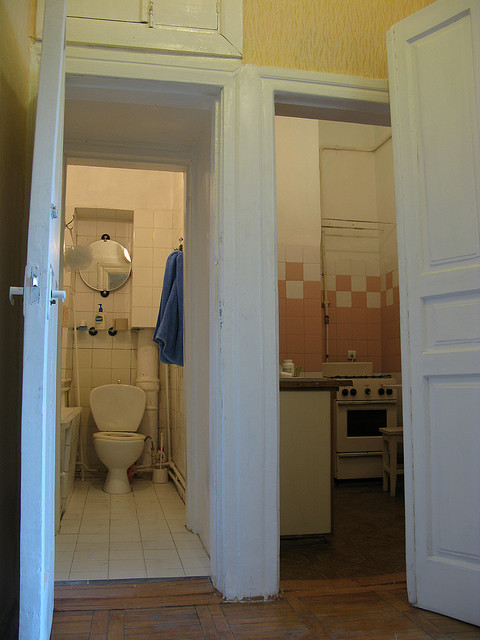<image>What type of wood is on the floor? I am not sure what type of wood is on the floor. It can be oak, hardwood or imitation. What type of wood is on the floor? I am not sure about the type of wood on the floor. It can be oak, hardwood, imitation, pressed wood, or parquet. 